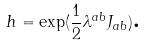<formula> <loc_0><loc_0><loc_500><loc_500>h = \exp ( \frac { 1 } { 2 } \lambda ^ { a b } J _ { a b } ) \text {.}</formula> 